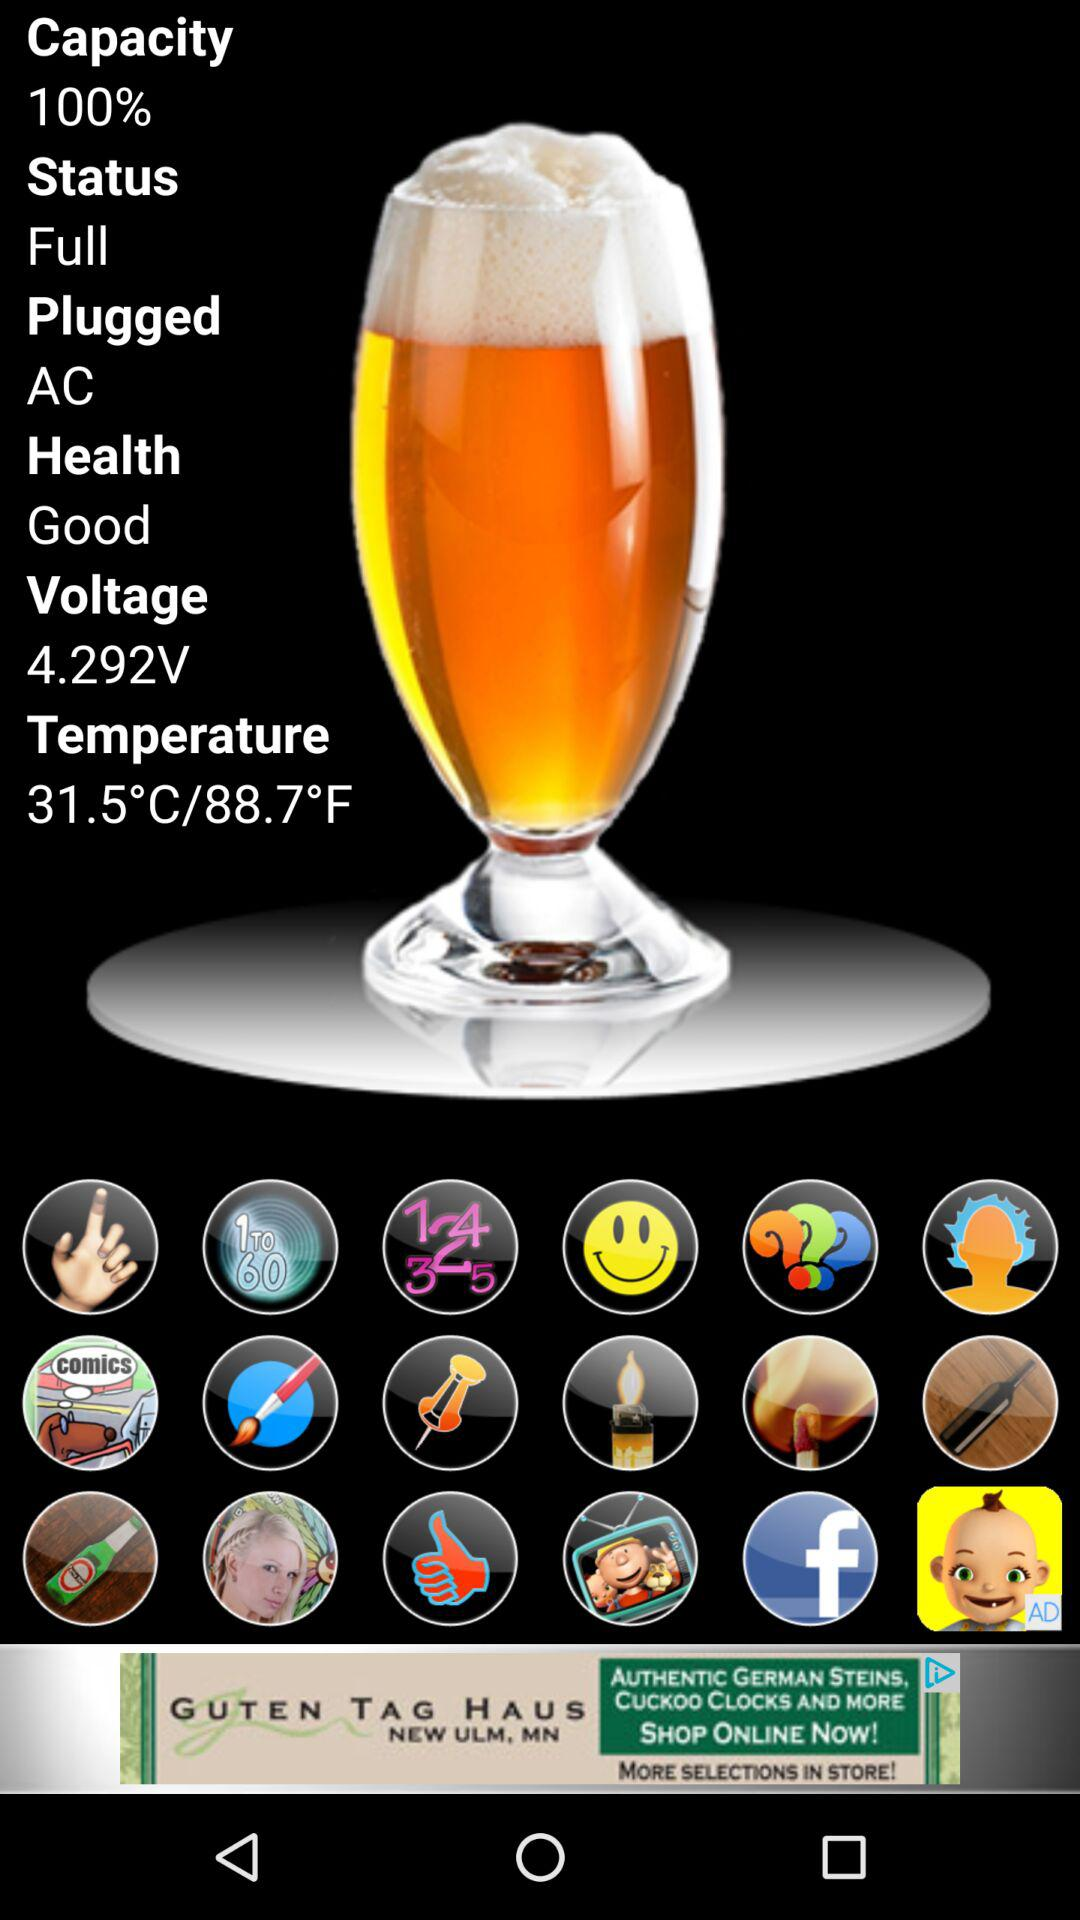What is the status of "Health"? The status of "Health" is "Good". 